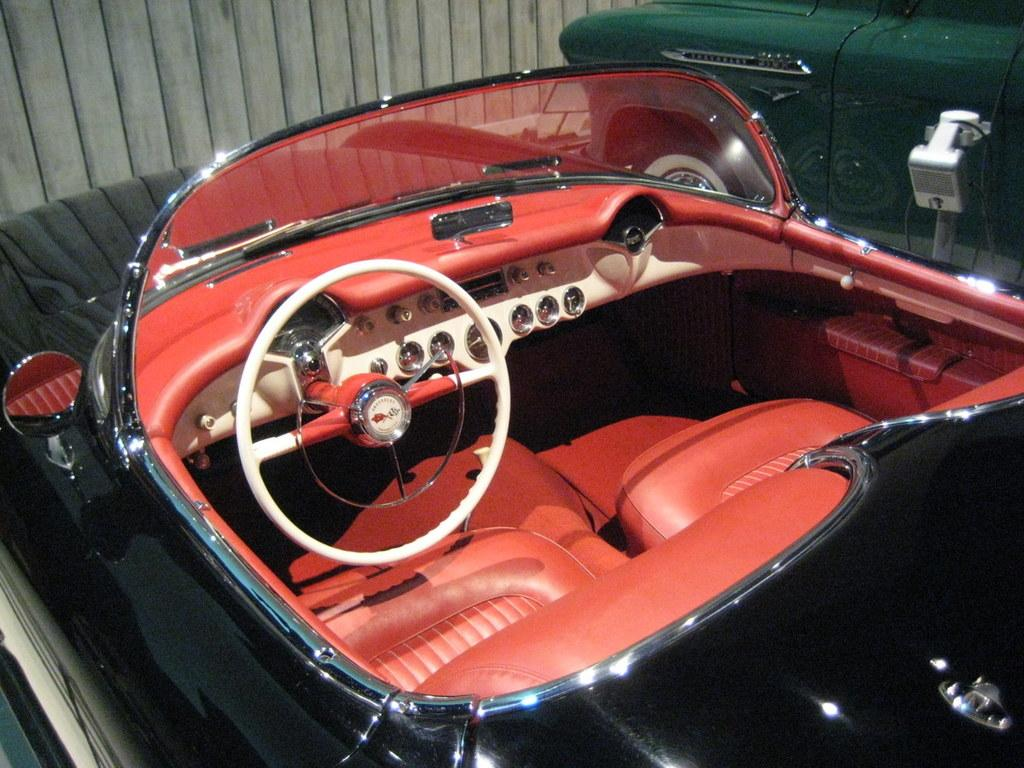What are the colors of the cars in the image? There is a black car and a green color car in the image. What type of material is the wall in the background made of? The wall in the background of the image is made of wood. What type of tax is being discussed in the image? There is no discussion of tax in the image; it features two cars and a wooden wall in the background. 